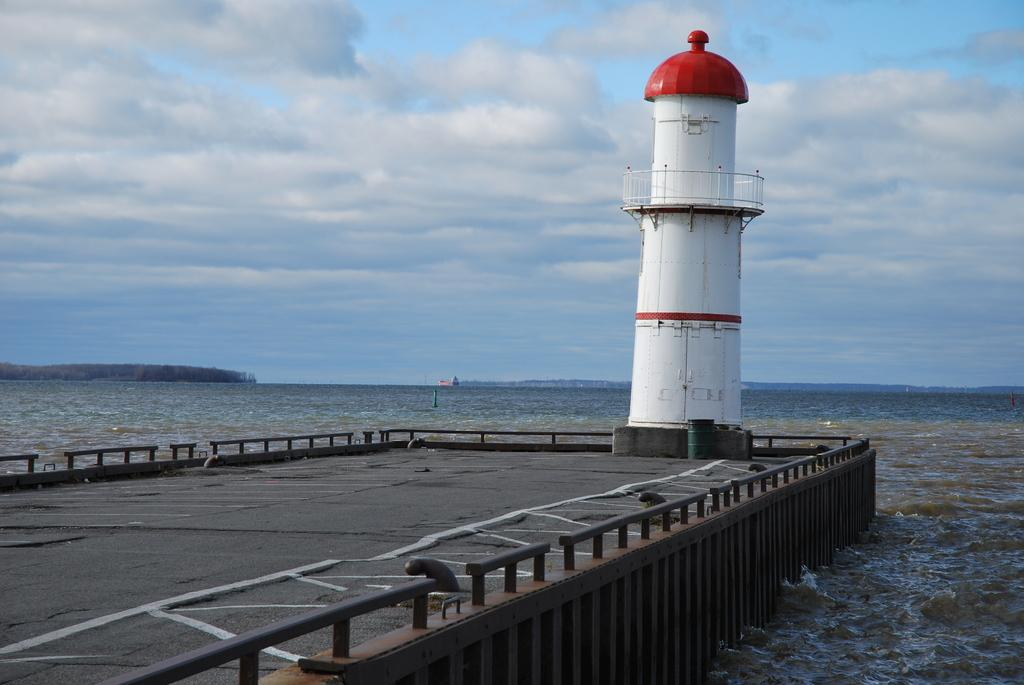What structure is the main subject of the image? There is a lighthouse in the image. What is the color of the lighthouse? The lighthouse is white in color. What can be seen in the background of the image? There is water and clouds in the sky visible in the background of the image. What part of the natural environment is visible in the image? The sky is visible in the background of the image. What type of noise can be heard coming from the lighthouse in the image? There is no indication of any noise in the image, as it is a still photograph. What subject is the lighthouse teaching in the image? The lighthouse is not a subject or entity capable of teaching, as it is an inanimate object. 